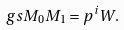Convert formula to latex. <formula><loc_0><loc_0><loc_500><loc_500>\ g s { M _ { 0 } } { M _ { 1 } } = p ^ { i } W .</formula> 